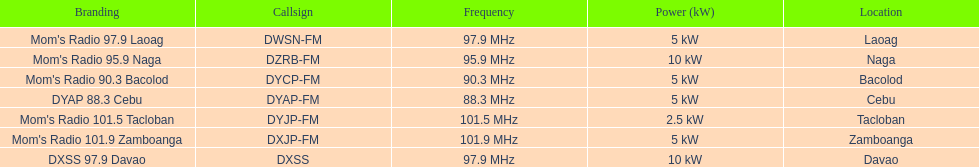Which of these stations broadcasts with the least power? Mom's Radio 101.5 Tacloban. Would you mind parsing the complete table? {'header': ['Branding', 'Callsign', 'Frequency', 'Power (kW)', 'Location'], 'rows': [["Mom's Radio 97.9 Laoag", 'DWSN-FM', '97.9\xa0MHz', '5\xa0kW', 'Laoag'], ["Mom's Radio 95.9 Naga", 'DZRB-FM', '95.9\xa0MHz', '10\xa0kW', 'Naga'], ["Mom's Radio 90.3 Bacolod", 'DYCP-FM', '90.3\xa0MHz', '5\xa0kW', 'Bacolod'], ['DYAP 88.3 Cebu', 'DYAP-FM', '88.3\xa0MHz', '5\xa0kW', 'Cebu'], ["Mom's Radio 101.5 Tacloban", 'DYJP-FM', '101.5\xa0MHz', '2.5\xa0kW', 'Tacloban'], ["Mom's Radio 101.9 Zamboanga", 'DXJP-FM', '101.9\xa0MHz', '5\xa0kW', 'Zamboanga'], ['DXSS 97.9 Davao', 'DXSS', '97.9\xa0MHz', '10\xa0kW', 'Davao']]} 